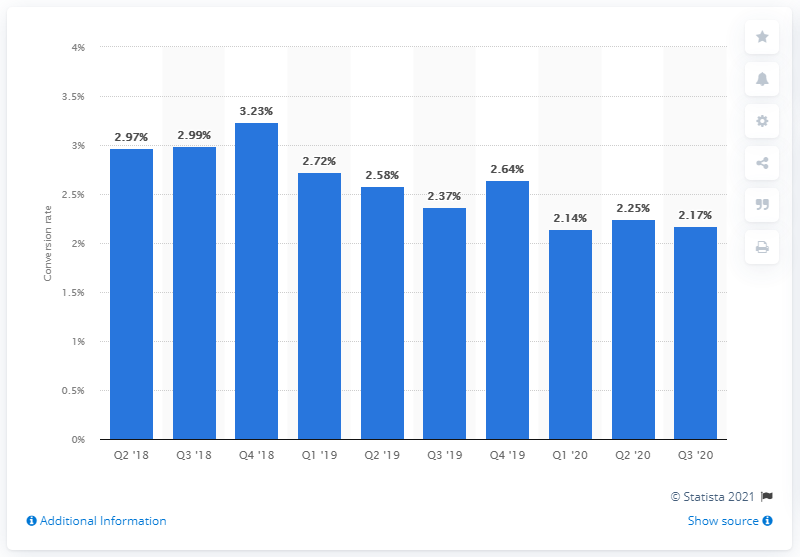Highlight a few significant elements in this photo. In the third quarter of 2020, the online shopper conversion rate in the US was 2.58%. 